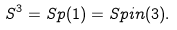Convert formula to latex. <formula><loc_0><loc_0><loc_500><loc_500>S ^ { 3 } = S p ( 1 ) = S p i n ( 3 ) .</formula> 